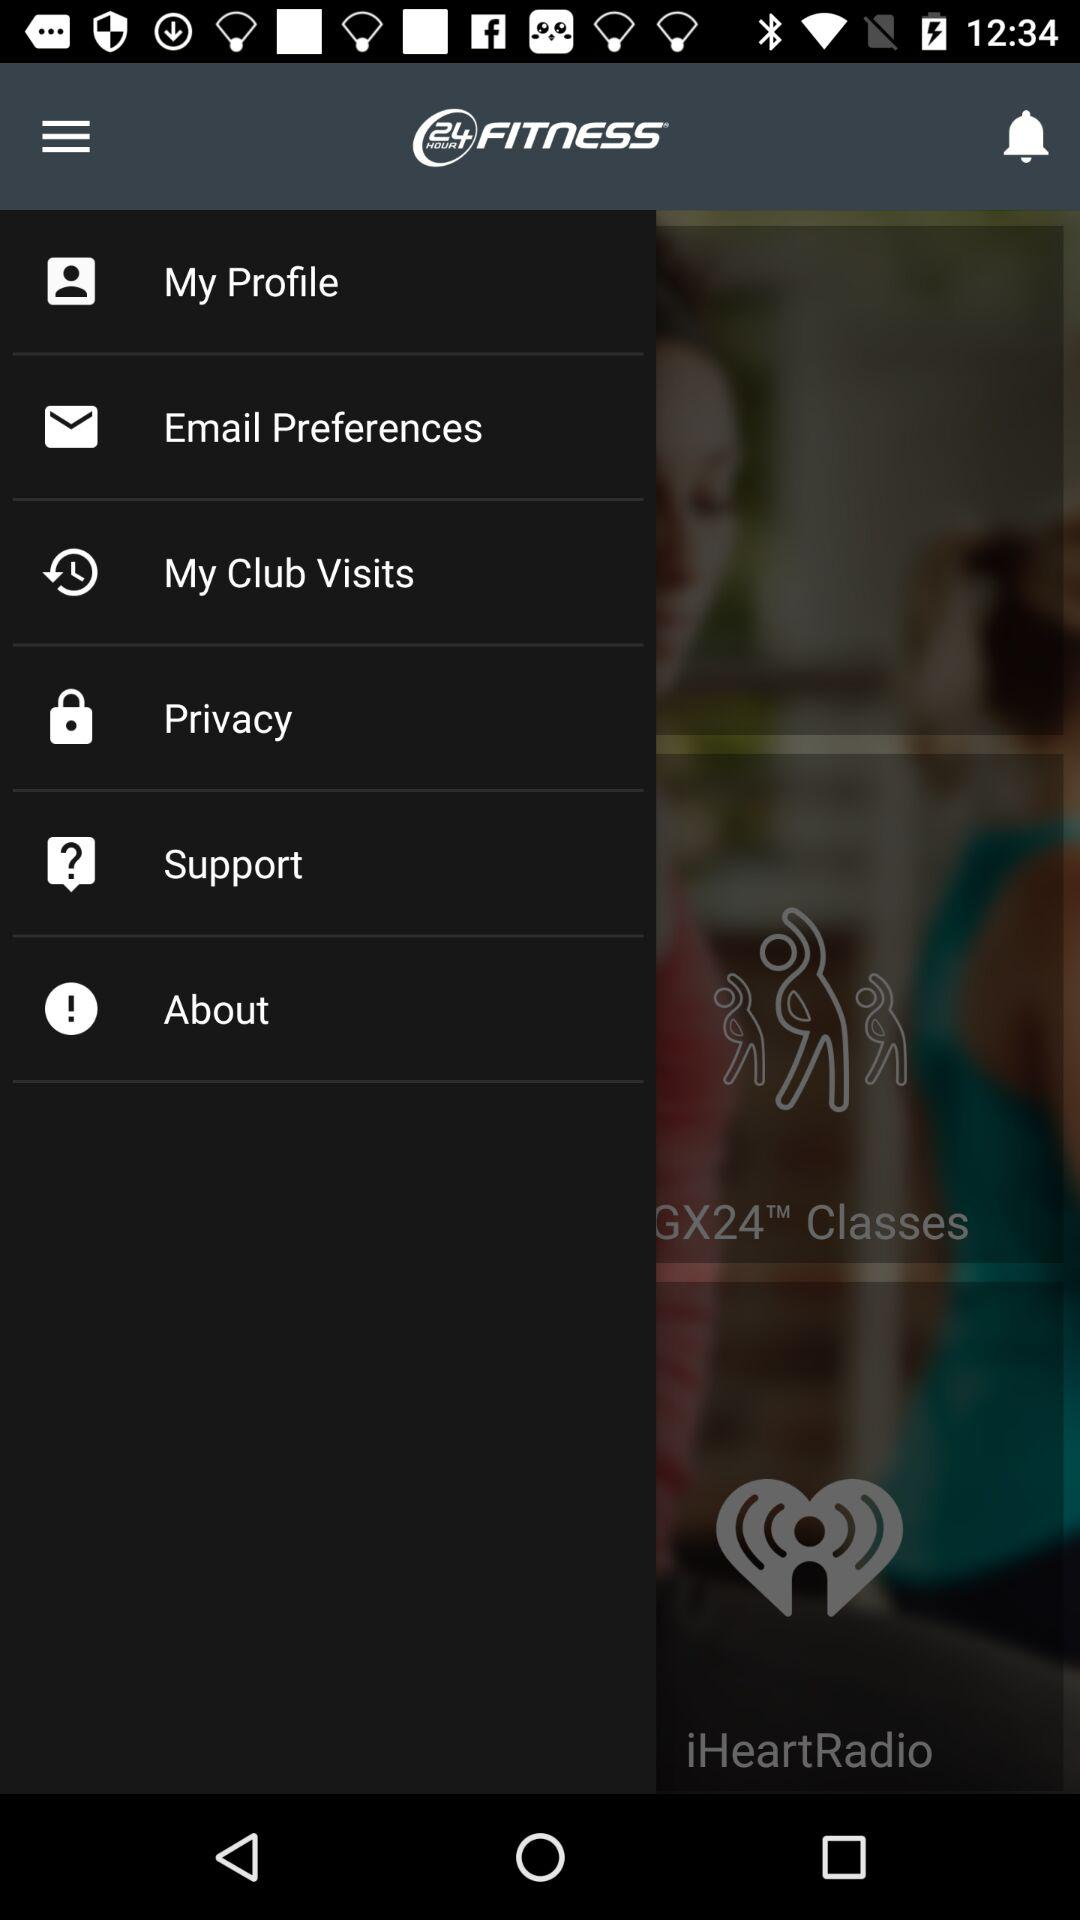What is the application name? The application name is "24 HOUR FITNESS". 